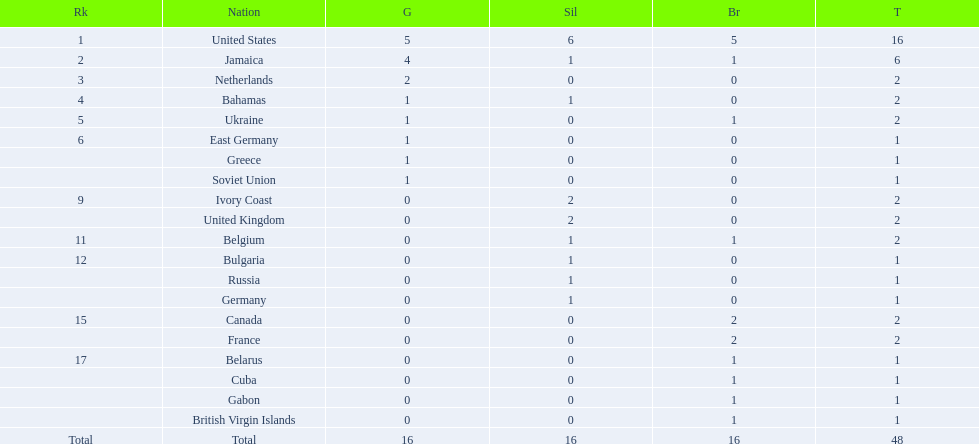What country won the most medals? United States. How many medals did the us win? 16. What is the most medals (after 16) that were won by a country? 6. Which country won 6 medals? Jamaica. 